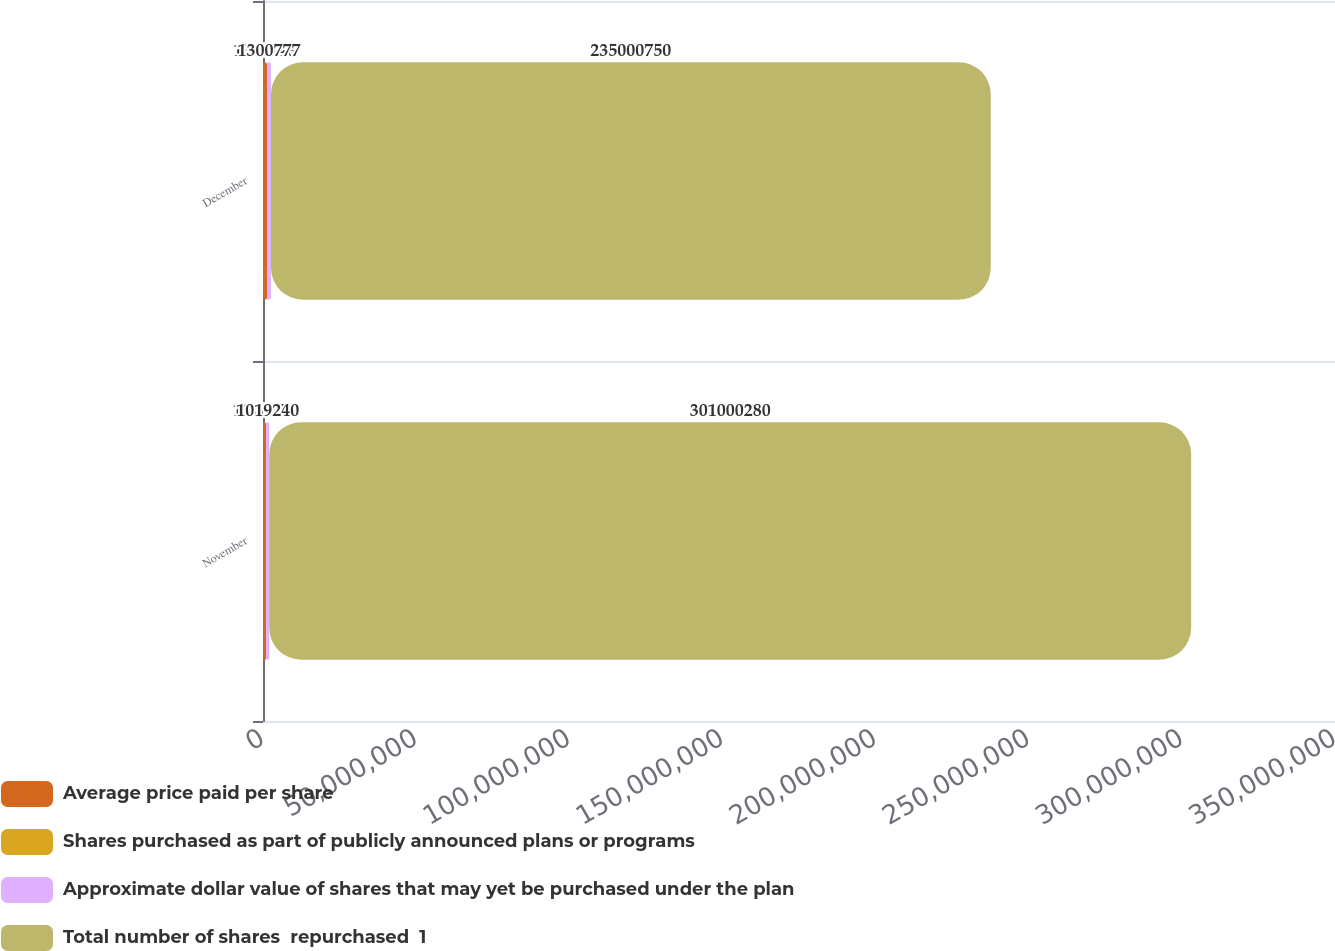Convert chart to OTSL. <chart><loc_0><loc_0><loc_500><loc_500><stacked_bar_chart><ecel><fcel>November<fcel>December<nl><fcel>Average price paid per share<fcel>1.0198e+06<fcel>1.30262e+06<nl><fcel>Shares purchased as part of publicly announced plans or programs<fcel>48.07<fcel>50.74<nl><fcel>Approximate dollar value of shares that may yet be purchased under the plan<fcel>1.01924e+06<fcel>1.30078e+06<nl><fcel>Total number of shares  repurchased  1<fcel>3.01e+08<fcel>2.35001e+08<nl></chart> 